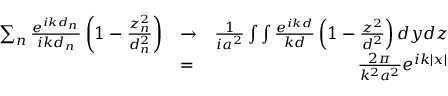Convert formula to latex. <formula><loc_0><loc_0><loc_500><loc_500>\begin{array} { r l r } { \sum _ { n } \frac { e ^ { i k d _ { n } } } { i k d _ { n } } \left ( 1 - \frac { z _ { n } ^ { 2 } } { d _ { n } ^ { 2 } } \right ) } & { \to } & { \frac { 1 } { i a ^ { 2 } } \int \int \frac { e ^ { i k d } } { k d } \left ( 1 - \frac { z ^ { 2 } } { d ^ { 2 } } \right ) d y d z } \\ & { = } & { \frac { 2 \pi } { k ^ { 2 } a ^ { 2 } } e ^ { i k | x | } } \end{array}</formula> 